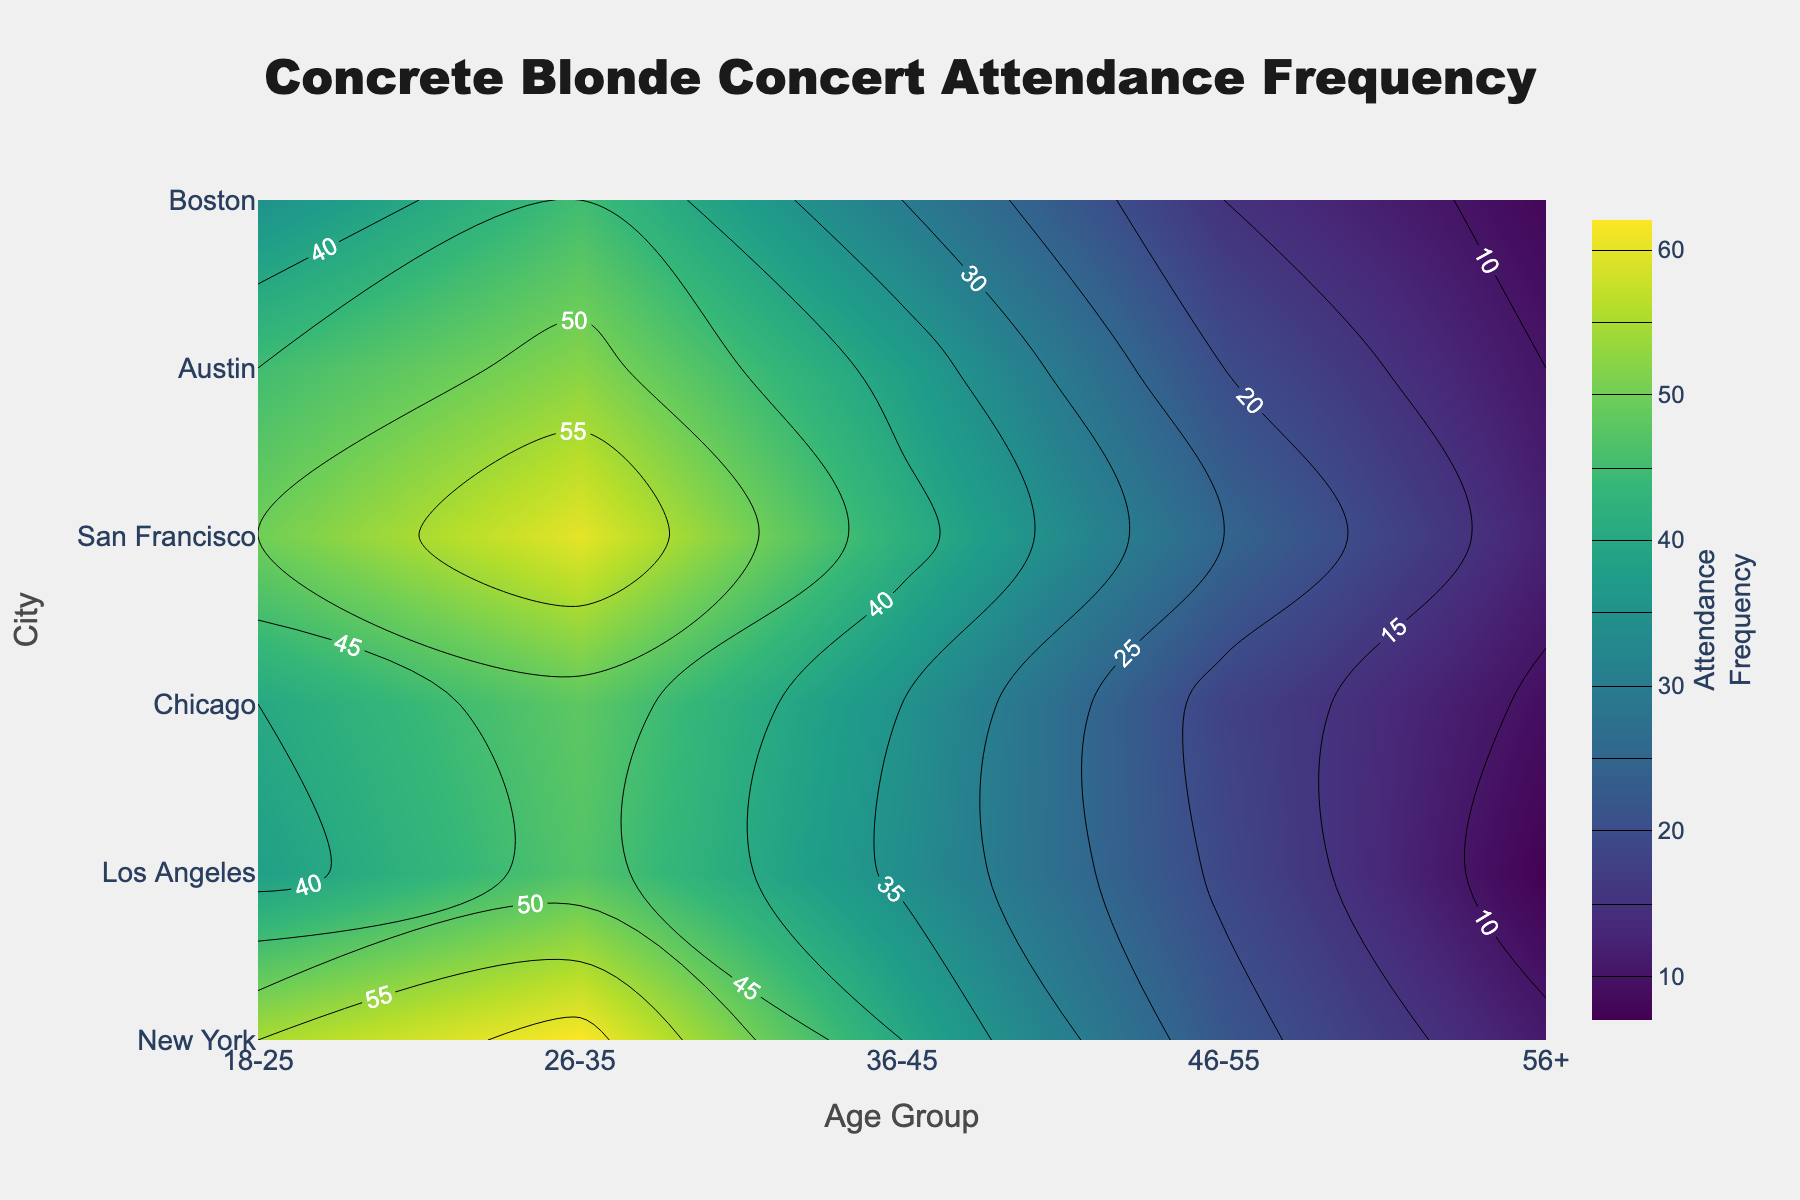How many Age Groups are represented in the contour plot? The x-axis represents the age groups, which are labeled. Counting these labels gives us the number of age groups.
Answer: 5 Which city has the highest attendance frequency for the 26-35 age group? Locate the row for the 26-35 age group and find the highest contour label in that row, which shows the highest value.
Answer: Austin Which city's 46-55 age group has the lowest attendance frequency? Locate the row for the 46-55 age group and find the lowest contour label value in that row.
Answer: Boston What is the attendance frequency difference between the 18-25 and 56+ age groups in New York? Look at the attendance frequencies for the 18-25 (45) and 56+ (10) age groups in New York and subtract the latter from the former: 45 - 10 = 35.
Answer: 35 Compare the attendance frequency between Austin and Chicago for the 36-45 age group. Which is higher? Locate the attendance frequency values for the 36-45 age group in both Austin (40) and Chicago (35), then compare them.
Answer: Austin What is the average attendance frequency for the city of Los Angeles across all age groups? Sum the attendance frequencies for Los Angeles [50, 60, 42, 25, 12] and divide by the number of age groups (5): (50+60+42+25+12) / 5.
Answer: 37.8 Which city has a more uniform attendance distribution across all age groups, New York or Boston? Check the contour labels for each age group in New York and Boston. Calculate the variance for better insight, but directly look for less variation visually.
Answer: New York For the 26-35 age group, rank the cities based on attendance frequency from highest to lowest. Examine the contour labels for the 26-35 age group across all cities and arrange them: Austin (62), Los Angeles (60), New York (52), Chicago (48), Boston (47), San Francisco (45).
Answer: Austin > Los Angeles > New York > Chicago > Boston > San Francisco How does the attendance frequency for the 18-25 age group in San Francisco compare to Boston? Locate the contour label values for the 18-25 age group in San Francisco (35) and Boston (38). Compare them to see which is higher.
Answer: Boston 